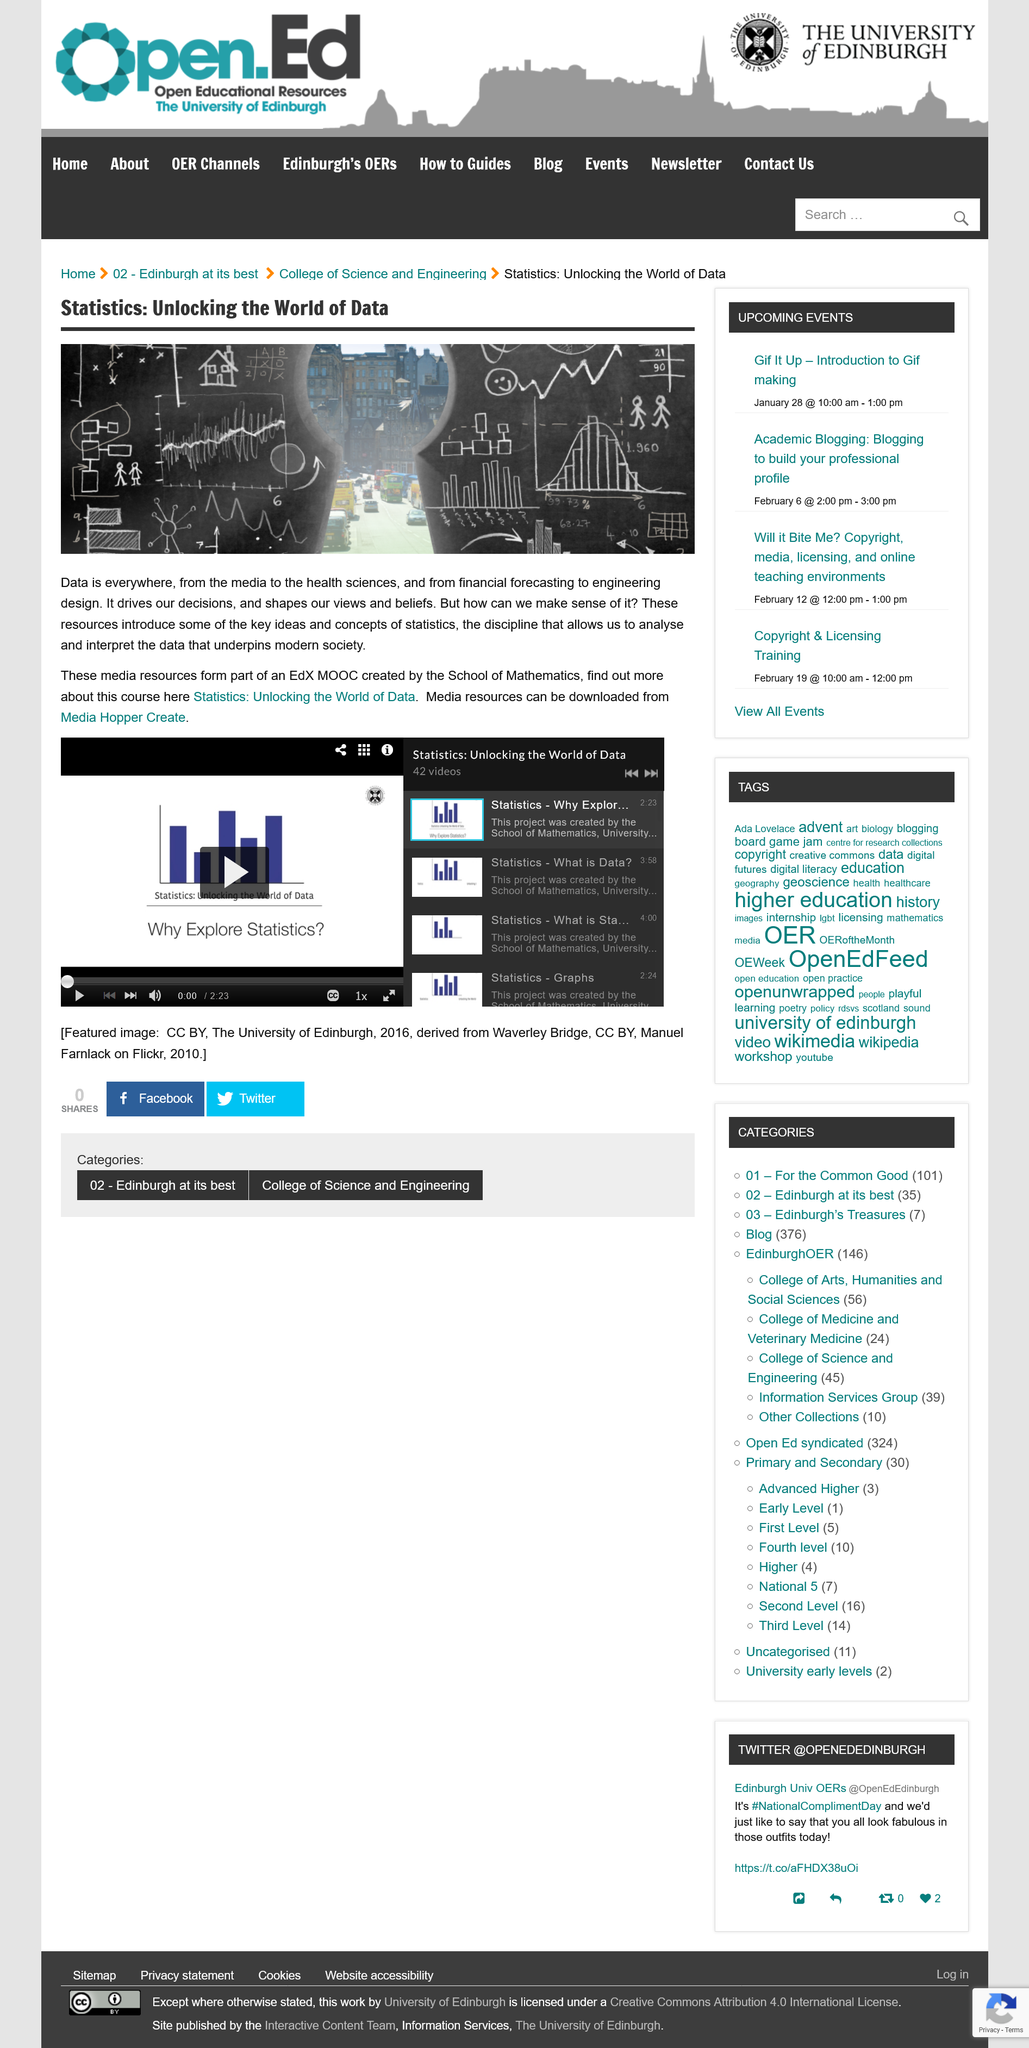Specify some key components in this picture. The media resources for this course can be downloaded from Media Hopper Create. The creator of the course "Statistics: Unlocking the World of Data" is the School of Mathematics. The Statistics: Unlocking the World of Data course is designed to provide students with the skills necessary to understand and interpret data, which is critical in today's data-driven society. 